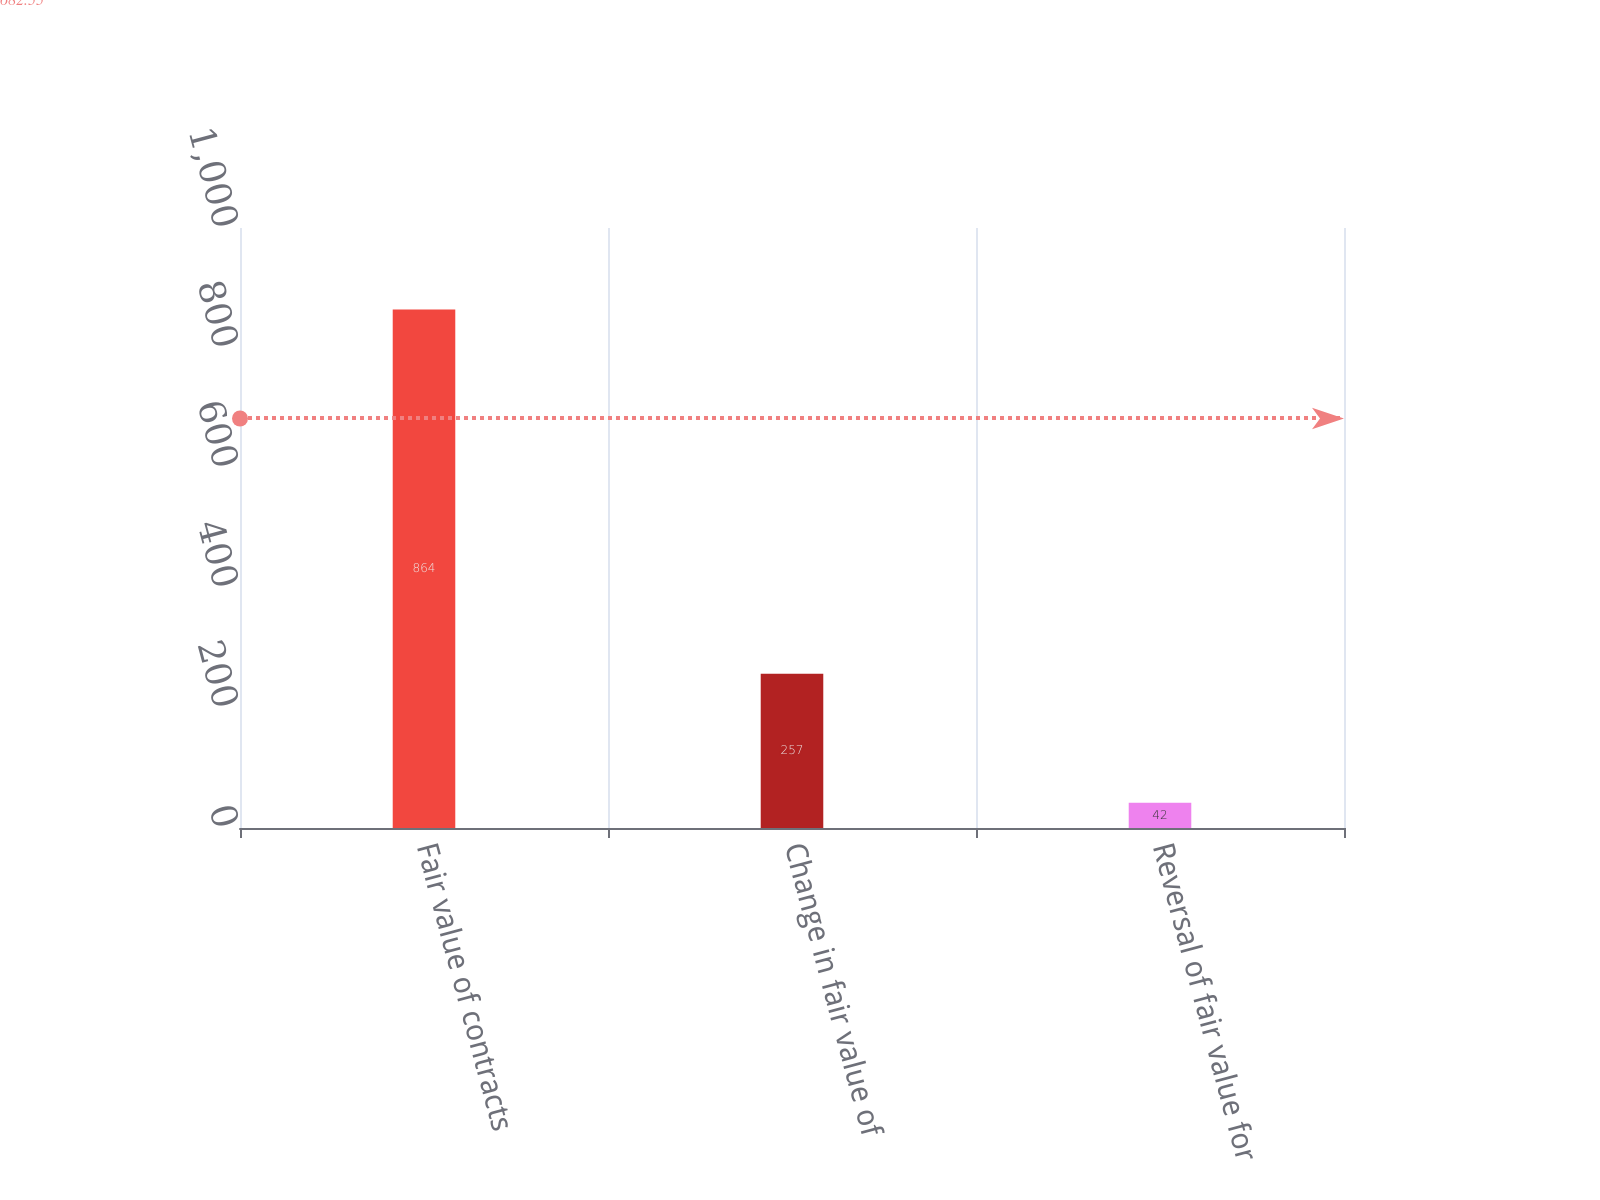Convert chart. <chart><loc_0><loc_0><loc_500><loc_500><bar_chart><fcel>Fair value of contracts<fcel>Change in fair value of<fcel>Reversal of fair value for<nl><fcel>864<fcel>257<fcel>42<nl></chart> 